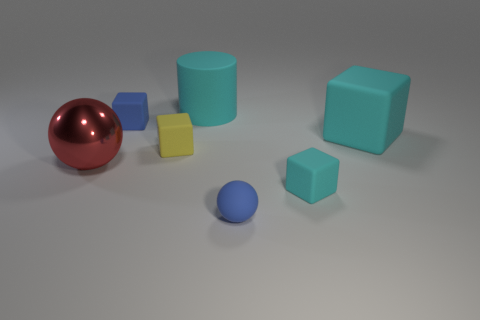There is a large rubber cylinder; is its color the same as the large rubber object in front of the small blue matte block? yes 